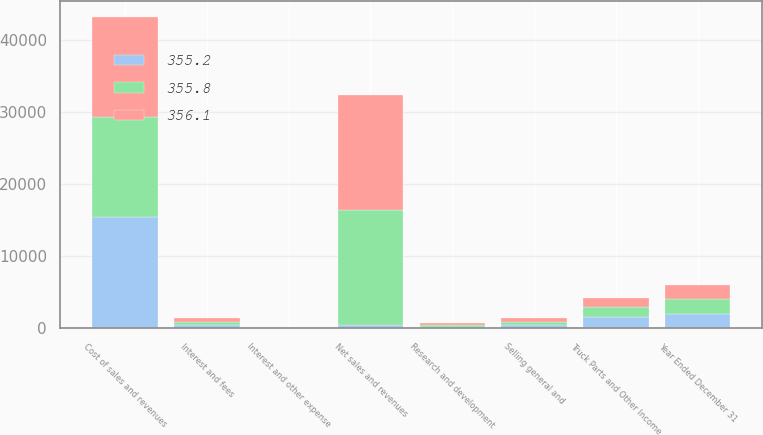Convert chart. <chart><loc_0><loc_0><loc_500><loc_500><stacked_bar_chart><ecel><fcel>Year Ended December 31<fcel>Net sales and revenues<fcel>Cost of sales and revenues<fcel>Research and development<fcel>Selling general and<fcel>Interest and other expense<fcel>Truck Parts and Other Income<fcel>Interest and fees<nl><fcel>355.2<fcel>2014<fcel>476.4<fcel>15481.6<fcel>215.6<fcel>465.2<fcel>5.5<fcel>1624.9<fcel>462.6<nl><fcel>355.8<fcel>2013<fcel>15948.9<fcel>13900.7<fcel>251.4<fcel>465.3<fcel>5.3<fcel>1326.2<fcel>462.8<nl><fcel>356.1<fcel>2012<fcel>15951.7<fcel>13908.3<fcel>279.3<fcel>476.4<fcel>0.3<fcel>1288<fcel>453.7<nl></chart> 